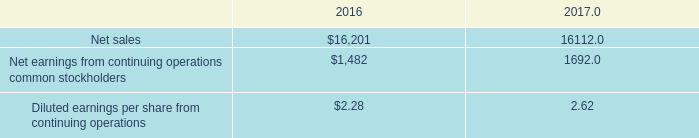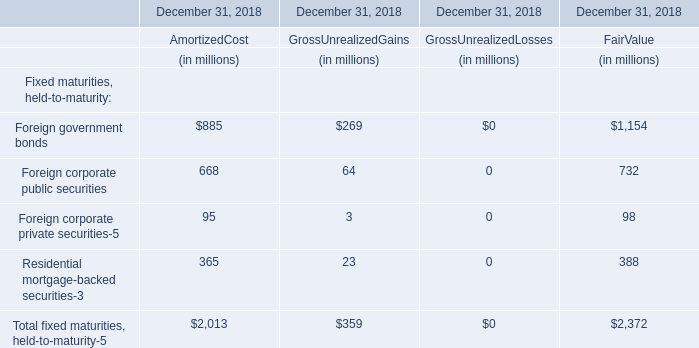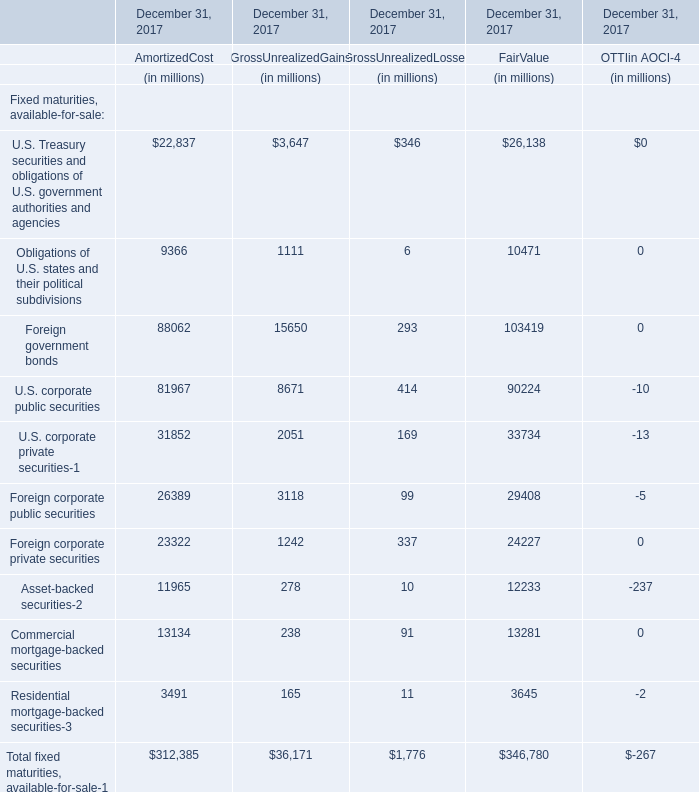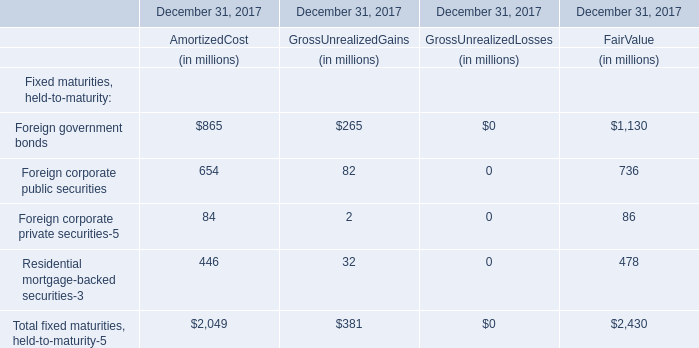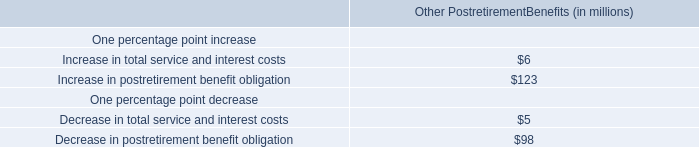The Total fixed maturities, held-to-maturity-5 amount of which section ranks first? 
Answer: Amortized Cost. 